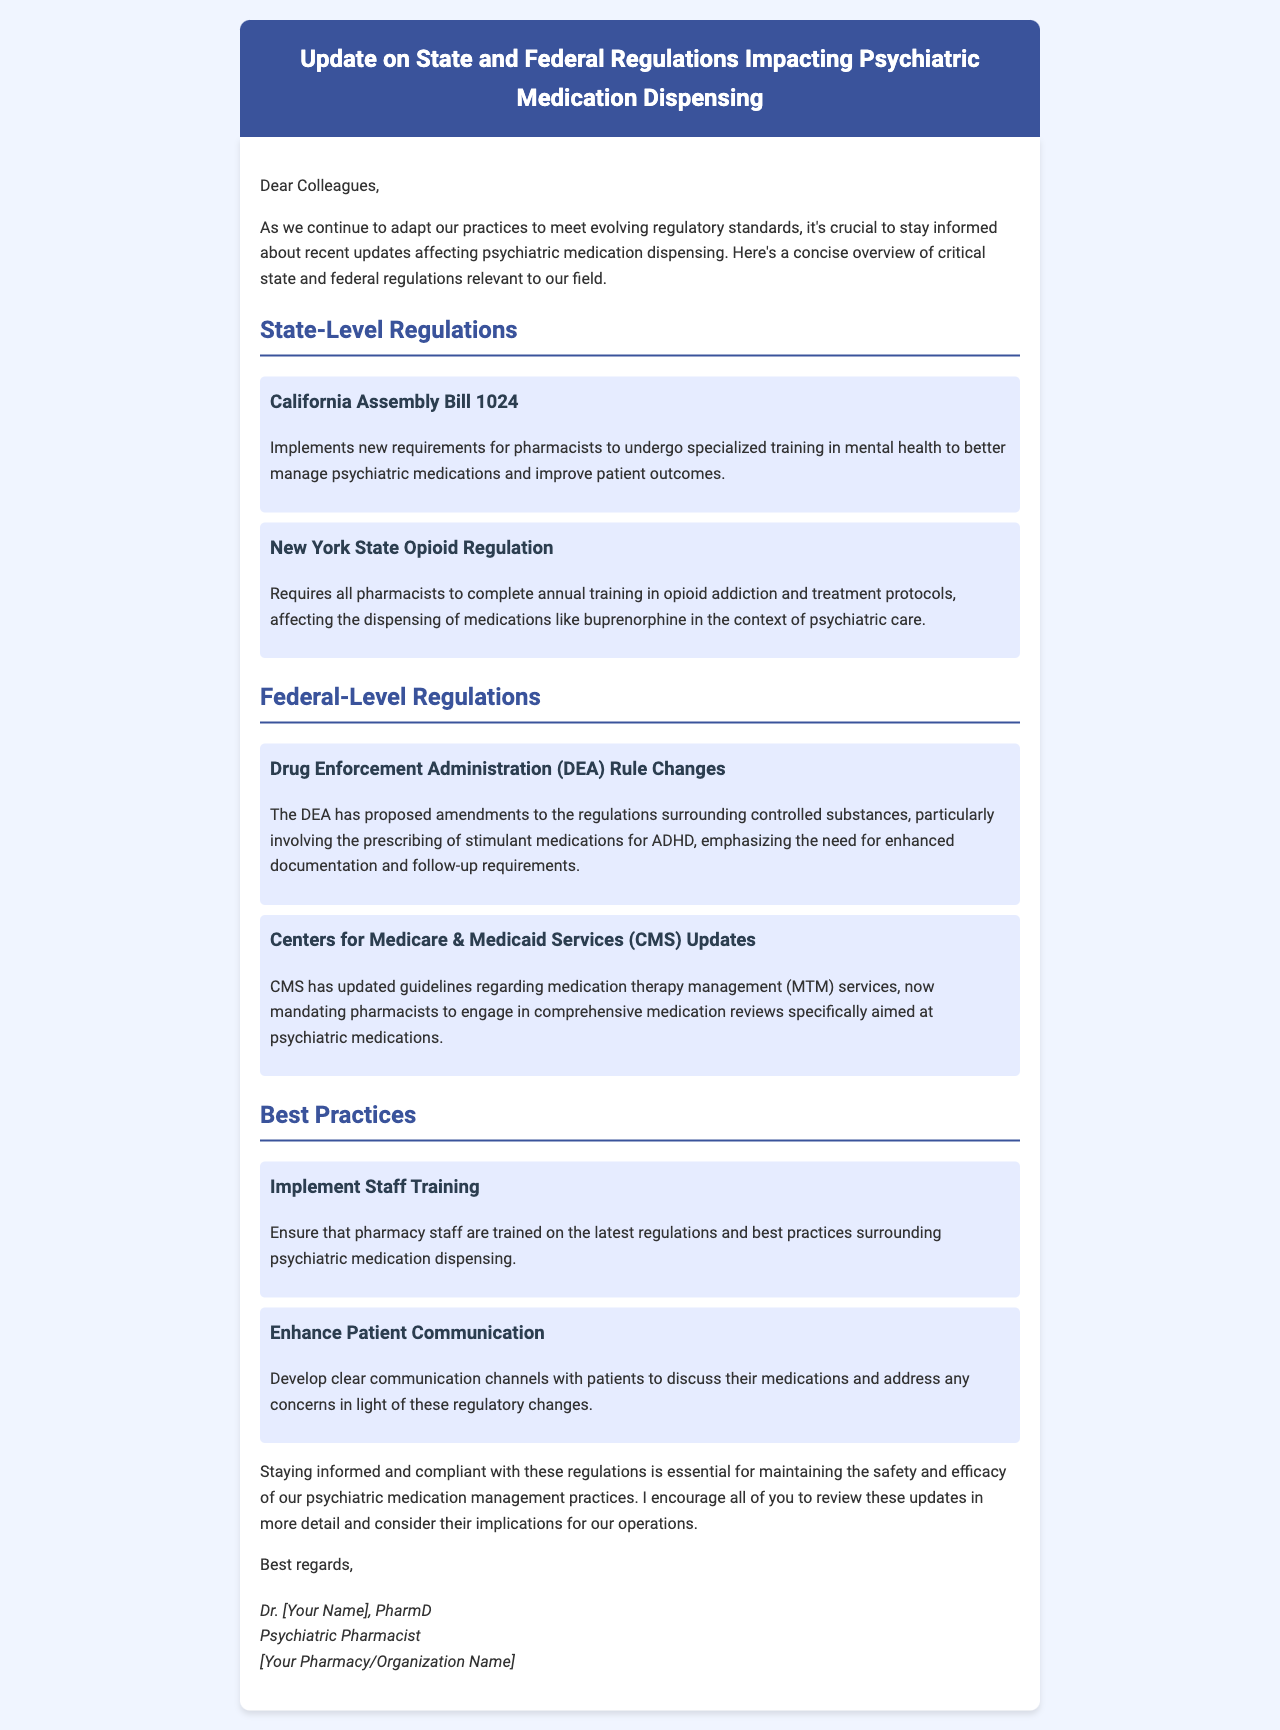What is the title of the document? The title of the document is presented prominently in the header section.
Answer: Update on State and Federal Regulations Impacting Psychiatric Medication Dispensing What does California Assembly Bill 1024 require? The bill requires pharmacists to undergo specialized training in mental health.
Answer: Specialized training in mental health What federal agency proposed amendments to controlled substances regulations? The specific federal agency mentioned in relation to controlled substances is detailed in the federal regulations section.
Answer: Drug Enforcement Administration (DEA) What is a requirement of New York State Opioid Regulation? The regulation requires pharmacists to complete annual training in opioid addiction and treatment protocols.
Answer: Annual training in opioid addiction What are two best practices suggested for pharmacy staff? The document outlines two best practices aimed at ensuring compliance and effective communication with patients.
Answer: Implement Staff Training, Enhance Patient Communication How many updates regarding medication therapy management services were mentioned? The document refers to one specific update regarding medication therapy management services by CMS.
Answer: One What is emphasized in the DEA rule changes? The proposed rule changes involve prescriptions specifically for ADHD medications, emphasizing a particular need.
Answer: Enhanced documentation and follow-up requirements Who authored the document? The author is stated at the end of the document in the signature section.
Answer: Dr. [Your Name] 